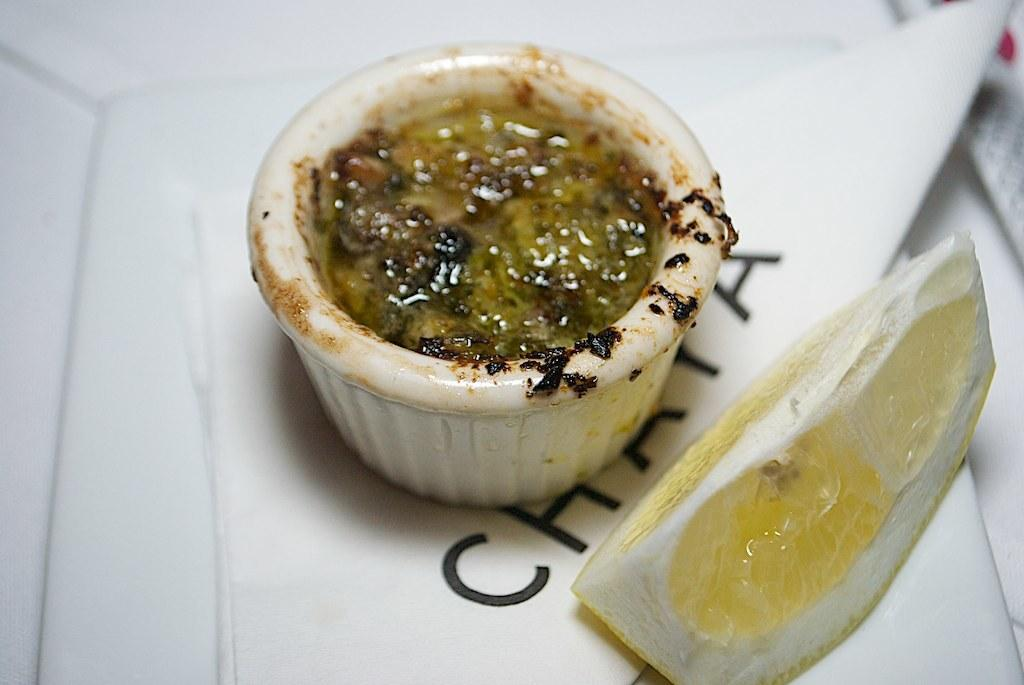What is the main subject in the center of the image? There is food in a cup in the center of the image. What other object can be seen in the image? There is a lemon placed on a paper in the image. What type of thought is being expressed by the badge in the image? There is no badge present in the image, so it is not possible to determine what thought might be expressed. 